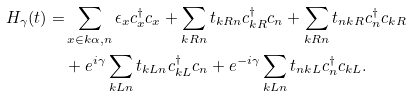Convert formula to latex. <formula><loc_0><loc_0><loc_500><loc_500>H _ { \gamma } ( t ) = & \sum _ { x \in k \alpha , n } \epsilon _ { x } c ^ { \dag } _ { x } c _ { x } + \sum _ { k R n } t _ { k R n } c ^ { \dag } _ { k R } c _ { n } + \sum _ { k R n } t _ { n k R } c ^ { \dag } _ { n } c _ { k R } \\ & + e ^ { i \gamma } \sum _ { k L n } t _ { k L n } c ^ { \dag } _ { k L } c _ { n } + e ^ { - i \gamma } \sum _ { k L n } t _ { n k L } c ^ { \dag } _ { n } c _ { k L } .</formula> 